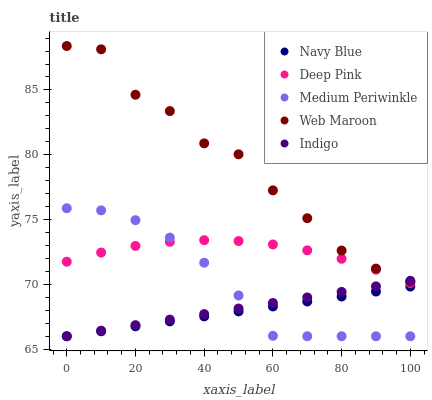Does Navy Blue have the minimum area under the curve?
Answer yes or no. Yes. Does Web Maroon have the maximum area under the curve?
Answer yes or no. Yes. Does Deep Pink have the minimum area under the curve?
Answer yes or no. No. Does Deep Pink have the maximum area under the curve?
Answer yes or no. No. Is Navy Blue the smoothest?
Answer yes or no. Yes. Is Web Maroon the roughest?
Answer yes or no. Yes. Is Deep Pink the smoothest?
Answer yes or no. No. Is Deep Pink the roughest?
Answer yes or no. No. Does Navy Blue have the lowest value?
Answer yes or no. Yes. Does Deep Pink have the lowest value?
Answer yes or no. No. Does Web Maroon have the highest value?
Answer yes or no. Yes. Does Deep Pink have the highest value?
Answer yes or no. No. Is Navy Blue less than Web Maroon?
Answer yes or no. Yes. Is Web Maroon greater than Deep Pink?
Answer yes or no. Yes. Does Deep Pink intersect Medium Periwinkle?
Answer yes or no. Yes. Is Deep Pink less than Medium Periwinkle?
Answer yes or no. No. Is Deep Pink greater than Medium Periwinkle?
Answer yes or no. No. Does Navy Blue intersect Web Maroon?
Answer yes or no. No. 